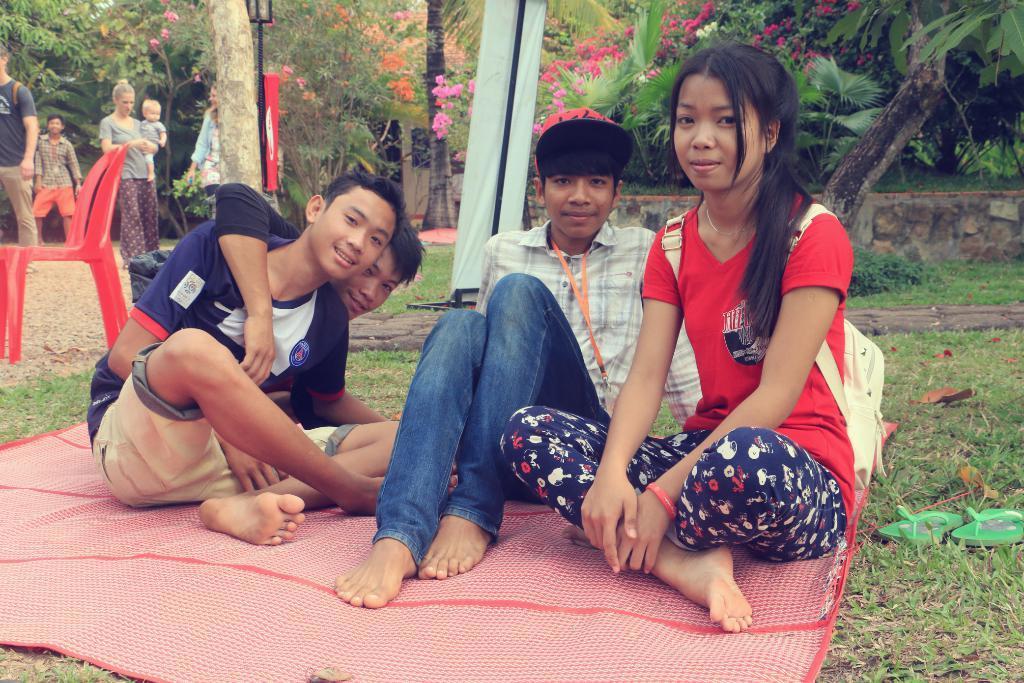Describe this image in one or two sentences. In this image we can see three boys and a girl sitting on the mat which is on the grass. We can also see the dried leaves, footwear on the right. In the background we can see the chair, board, people, banner and also the trees. We can also see the wall and also the sand. 